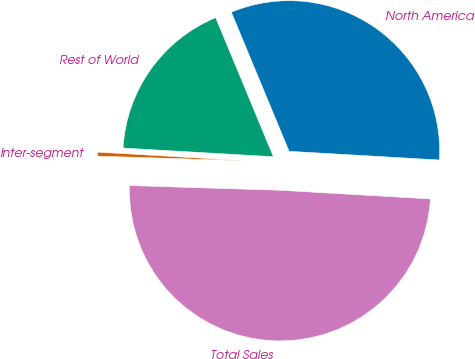Convert chart. <chart><loc_0><loc_0><loc_500><loc_500><pie_chart><fcel>North America<fcel>Rest of World<fcel>Inter-segment<fcel>Total Sales<nl><fcel>32.18%<fcel>17.82%<fcel>0.42%<fcel>49.58%<nl></chart> 